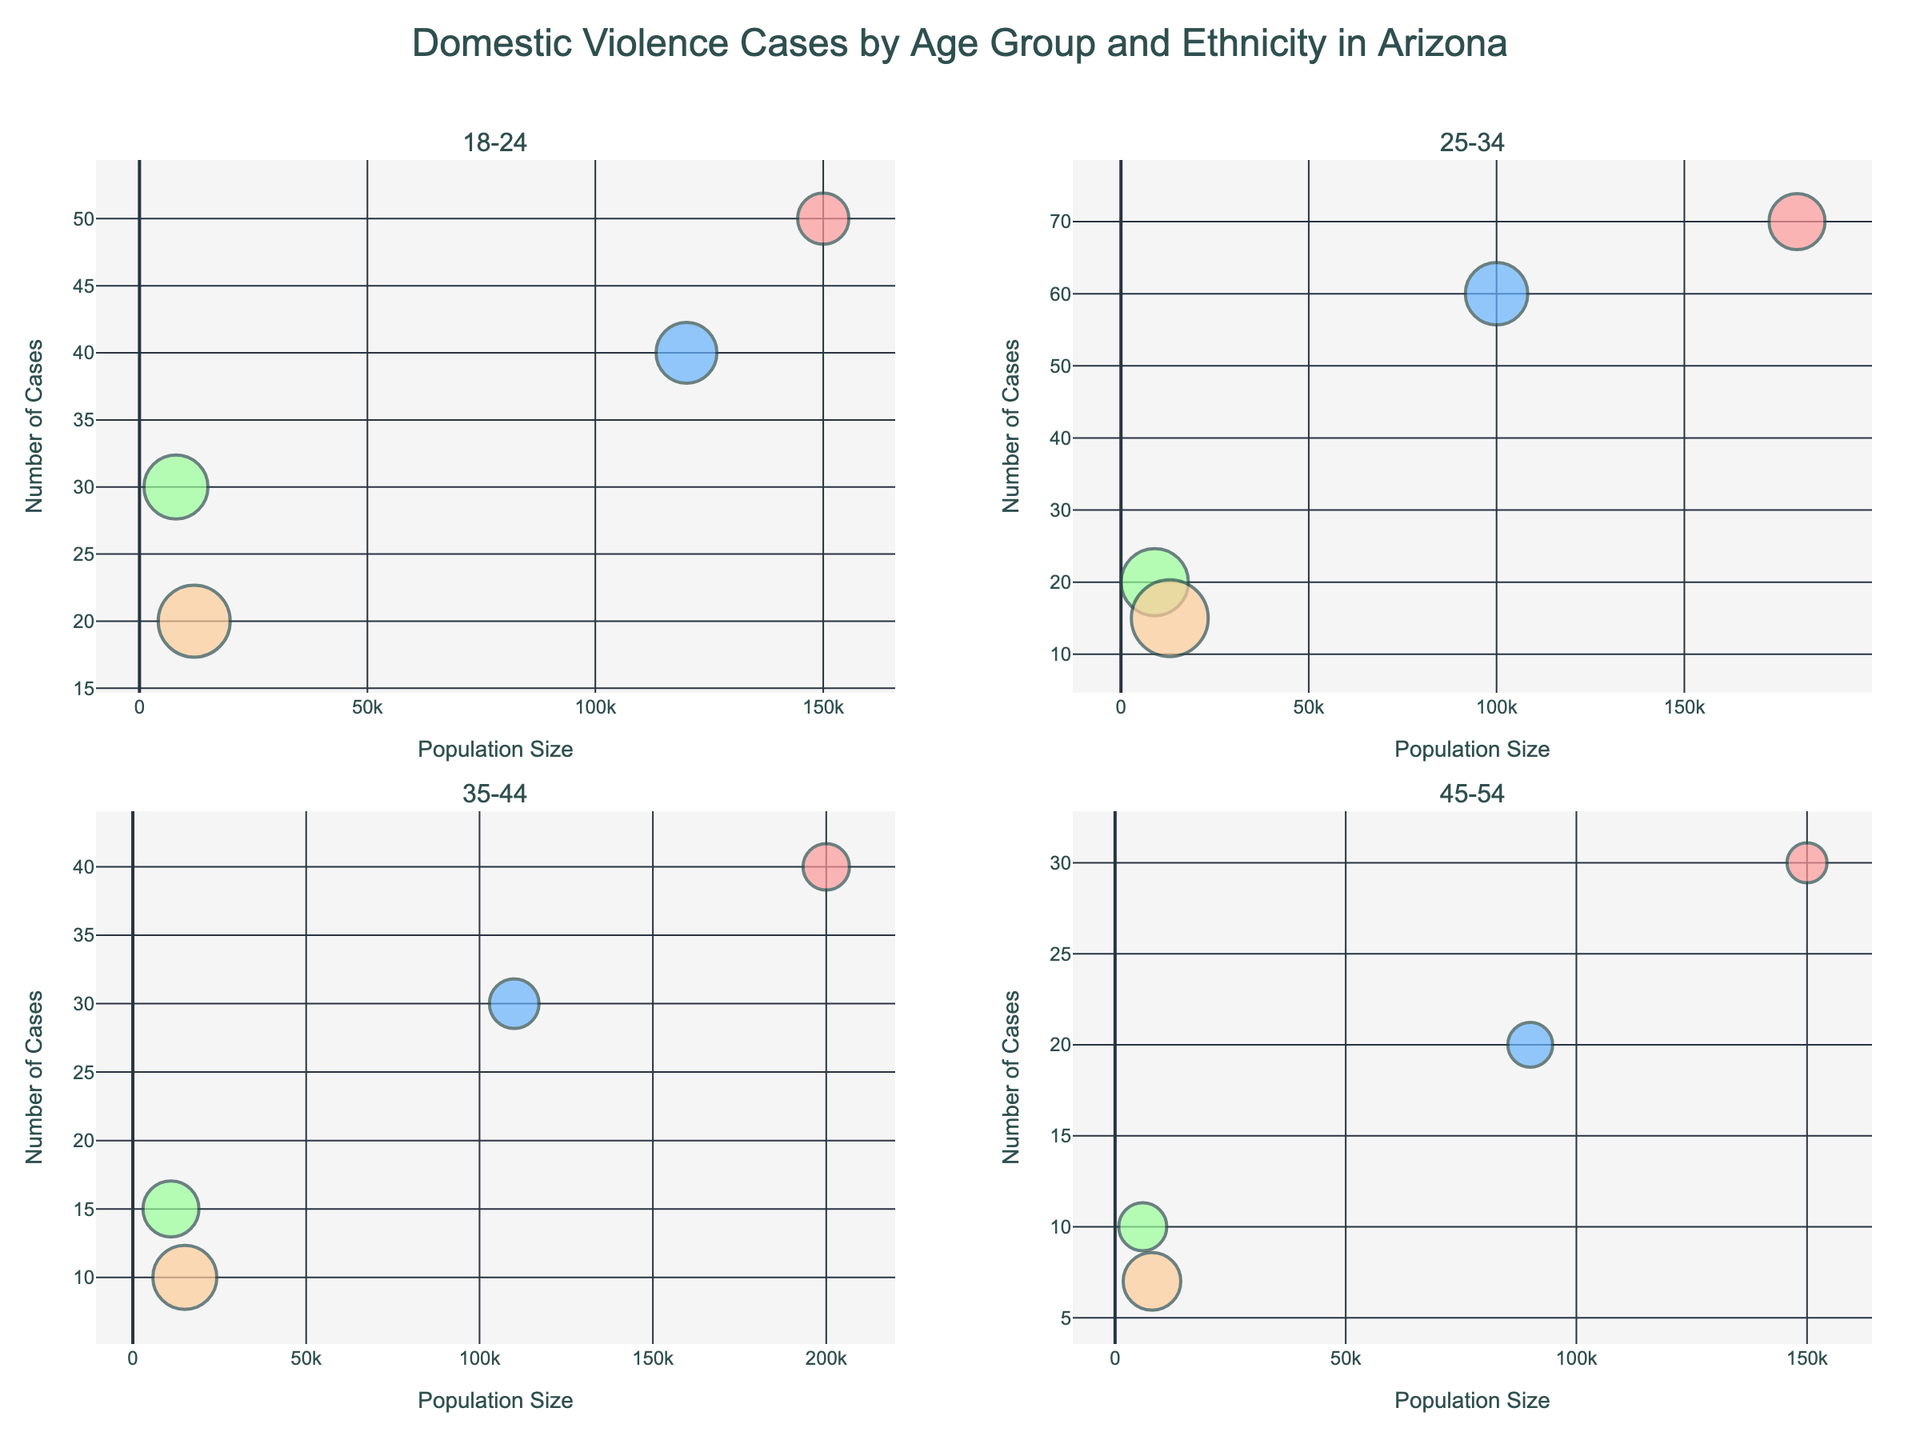What's the age group with the highest number of domestic violence cases reported for all ethnicities combined? To find the answer, add the number of cases reported for each ethnicity within each age group and compare. For 18-24, the total is 50 (White) + 40 (Hispanic) + 30 (Black) + 20 (Native American) = 140. For 25-34, it is 70 (White) + 60 (Hispanic) + 20 (Black) + 15 (Native American) = 165. For 35-44, it is 40 (White) + 30 (Hispanic) + 15 (Black) + 10 (Native American) = 95. For 45-54, it is 30 (White) + 20 (Hispanic) + 10 (Black) + 7 (Native American) = 67. The 25-34 age group has the highest total number of cases.
Answer: 25-34 Which ethnicity has the largest average severity in the 35-44 age group? Look at the average severity values for each ethnicity in the 35-44 age group: White (2.9), Hispanic (3.1), Black (3.5), and Native American (4.0). The highest average severity is 4.0 for Native American.
Answer: Native American What is the total population size for the 18-24 age group? Sum the populations of all ethnicities within the 18-24 age group: 150,000 (White) + 120,000 (Hispanic) + 8,000 (Black) + 12,000 (Native American) = 290,000.
Answer: 290,000 In the 25-34 age group, which ethnicity has the second highest number of cases? Look at the number of cases for each ethnicity within the 25-34 age group: White (70), Hispanic (60), Black (20), and Native American (15). The second highest number is 60, which belongs to Hispanic.
Answer: Hispanic Compare the average severity of domestic violence cases for the Black ethnicity across each age group. Which age group shows the lowest severity? Look at the average severity for Black ethnicity in each age group: 18-24 (4.0), 25-34 (4.2), 35-44 (3.5), and 45-54 (3.0). The lowest average severity is in the 45-54 age group at 3.0.
Answer: 45-54 Which age group and ethnicity combination has the smallest marker size on the bubble chart? Smallest marker size corresponds to the lowest average severity value. Find the lowest average severity values and compare: White (45-54, 2.5), Hispanic (45-54, 2.8), Black (45-54, 3.0), Native American (45-54, 3.6). The smallest average severity is 2.5 for White in the 45-54 age group.
Answer: White in 45-54 In the 35-44 age group, which ethnicity has the third highest population size? Look at the population sizes for each ethnicity within the 35-44 age group: White (200,000), Hispanic (110,000), Black (11,000), and Native American (15,000). The third highest population size is 15,000 for Native American.
Answer: Native American How does the number of cases reported by Native Americans in the 18-24 age group compare to that in the 25-34 age group? Compare the number of cases for Native Americans in both age groups: 18-24 (20 cases) and 25-34 (15 cases). The number of cases in the 18-24 age group is higher by 5 cases.
Answer: 18-24 has more cases 